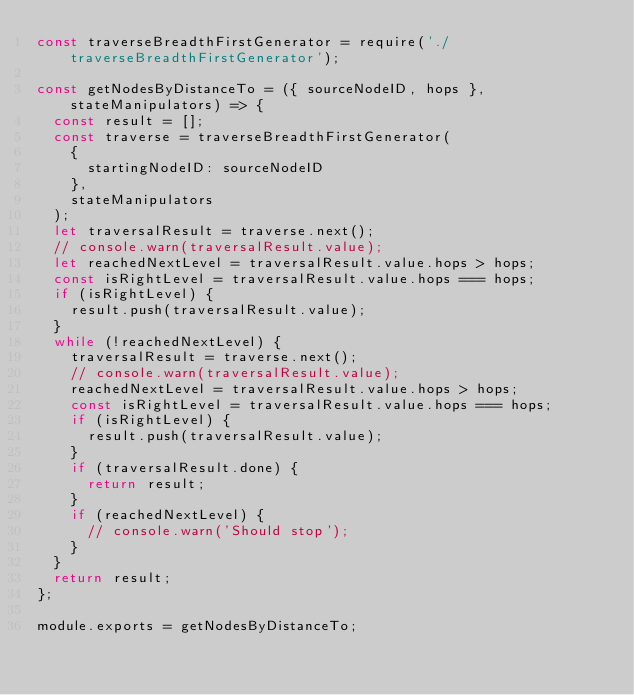Convert code to text. <code><loc_0><loc_0><loc_500><loc_500><_JavaScript_>const traverseBreadthFirstGenerator = require('./traverseBreadthFirstGenerator');

const getNodesByDistanceTo = ({ sourceNodeID, hops }, stateManipulators) => {
  const result = [];
  const traverse = traverseBreadthFirstGenerator(
    {
      startingNodeID: sourceNodeID
    },
    stateManipulators
  );
  let traversalResult = traverse.next();
  // console.warn(traversalResult.value);
  let reachedNextLevel = traversalResult.value.hops > hops;
  const isRightLevel = traversalResult.value.hops === hops;
  if (isRightLevel) {
    result.push(traversalResult.value);
  }
  while (!reachedNextLevel) {
    traversalResult = traverse.next();
    // console.warn(traversalResult.value);
    reachedNextLevel = traversalResult.value.hops > hops;
    const isRightLevel = traversalResult.value.hops === hops;
    if (isRightLevel) {
      result.push(traversalResult.value);
    }
    if (traversalResult.done) {
      return result;
    }
    if (reachedNextLevel) {
      // console.warn('Should stop');
    }
  }
  return result;
};

module.exports = getNodesByDistanceTo;
</code> 